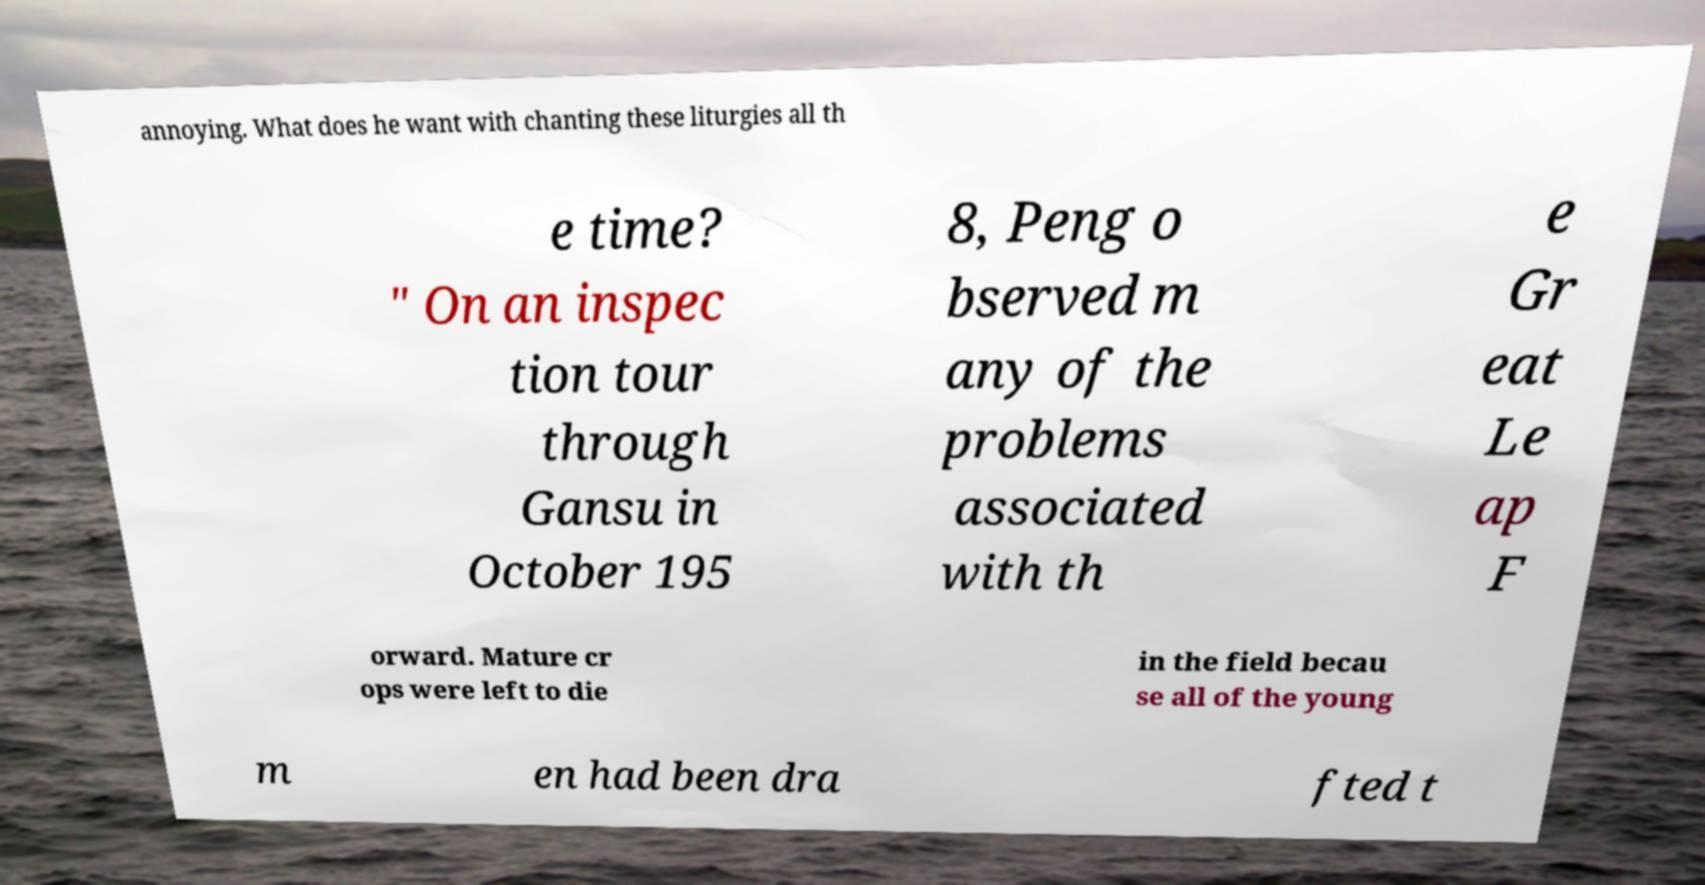Please read and relay the text visible in this image. What does it say? annoying. What does he want with chanting these liturgies all th e time? " On an inspec tion tour through Gansu in October 195 8, Peng o bserved m any of the problems associated with th e Gr eat Le ap F orward. Mature cr ops were left to die in the field becau se all of the young m en had been dra fted t 